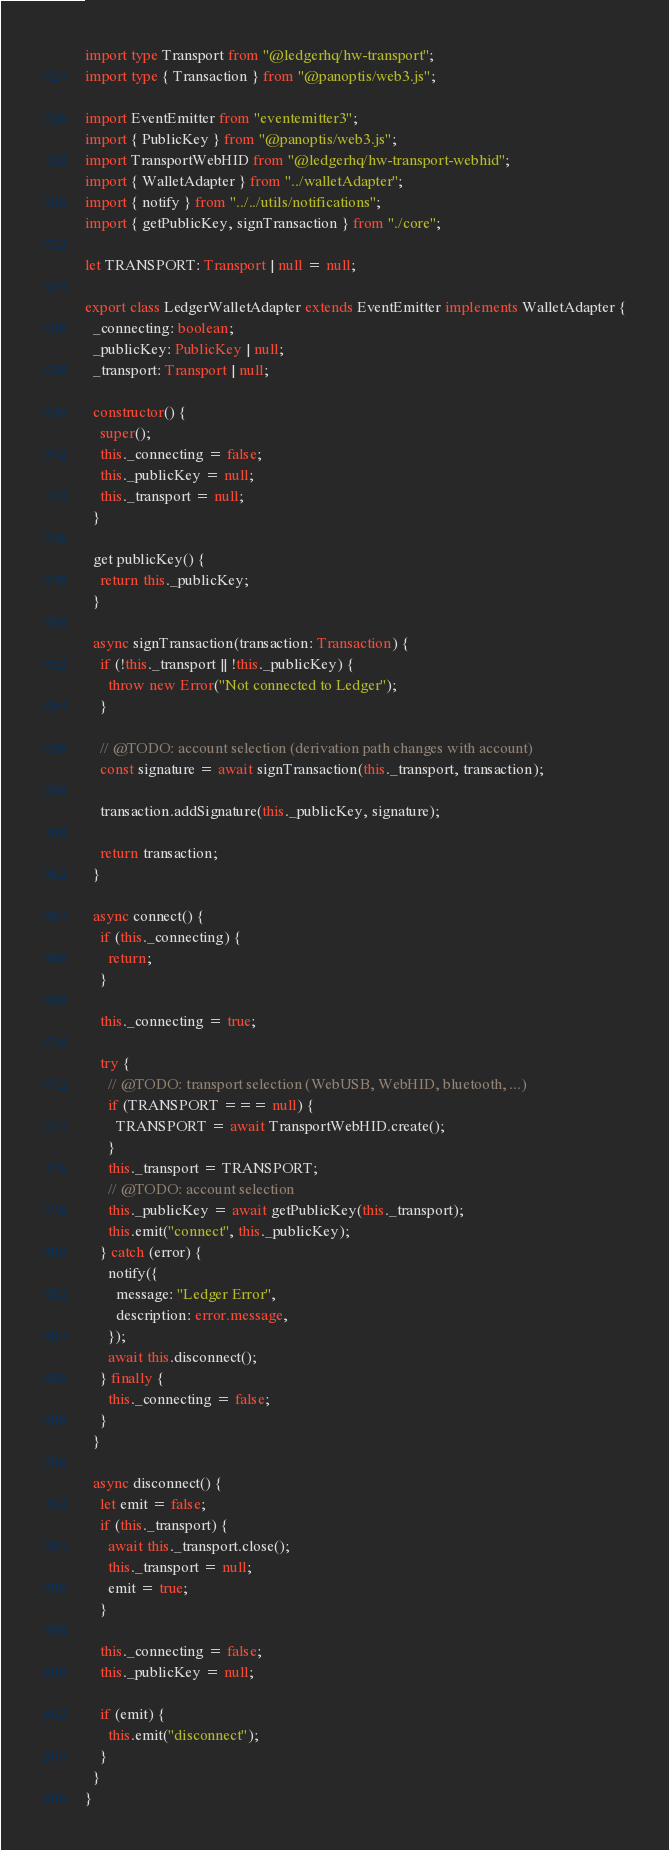Convert code to text. <code><loc_0><loc_0><loc_500><loc_500><_TypeScript_>import type Transport from "@ledgerhq/hw-transport";
import type { Transaction } from "@panoptis/web3.js";

import EventEmitter from "eventemitter3";
import { PublicKey } from "@panoptis/web3.js";
import TransportWebHID from "@ledgerhq/hw-transport-webhid";
import { WalletAdapter } from "../walletAdapter";
import { notify } from "../../utils/notifications";
import { getPublicKey, signTransaction } from "./core";

let TRANSPORT: Transport | null = null;

export class LedgerWalletAdapter extends EventEmitter implements WalletAdapter {
  _connecting: boolean;
  _publicKey: PublicKey | null;
  _transport: Transport | null;

  constructor() {
    super();
    this._connecting = false;
    this._publicKey = null;
    this._transport = null;
  }

  get publicKey() {
    return this._publicKey;
  }

  async signTransaction(transaction: Transaction) {
    if (!this._transport || !this._publicKey) {
      throw new Error("Not connected to Ledger");
    }

    // @TODO: account selection (derivation path changes with account)
    const signature = await signTransaction(this._transport, transaction);

    transaction.addSignature(this._publicKey, signature);

    return transaction;
  }

  async connect() {
    if (this._connecting) {
      return;
    }

    this._connecting = true;

    try {
      // @TODO: transport selection (WebUSB, WebHID, bluetooth, ...)
      if (TRANSPORT === null) {
        TRANSPORT = await TransportWebHID.create();
      }
      this._transport = TRANSPORT;
      // @TODO: account selection
      this._publicKey = await getPublicKey(this._transport);
      this.emit("connect", this._publicKey);
    } catch (error) {
      notify({
        message: "Ledger Error",
        description: error.message,
      });
      await this.disconnect();
    } finally {
      this._connecting = false;
    }
  }

  async disconnect() {
    let emit = false;
    if (this._transport) {
      await this._transport.close();
      this._transport = null;
      emit = true;
    }

    this._connecting = false;
    this._publicKey = null;

    if (emit) {
      this.emit("disconnect");
    }
  }
}
</code> 